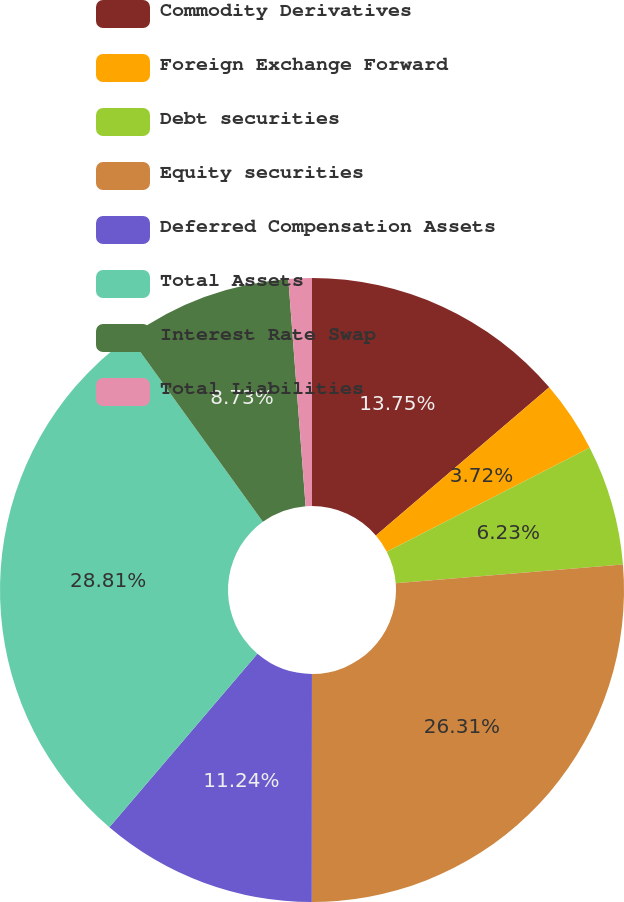<chart> <loc_0><loc_0><loc_500><loc_500><pie_chart><fcel>Commodity Derivatives<fcel>Foreign Exchange Forward<fcel>Debt securities<fcel>Equity securities<fcel>Deferred Compensation Assets<fcel>Total Assets<fcel>Interest Rate Swap<fcel>Total Liabilities<nl><fcel>13.75%<fcel>3.72%<fcel>6.23%<fcel>26.31%<fcel>11.24%<fcel>28.81%<fcel>8.73%<fcel>1.21%<nl></chart> 